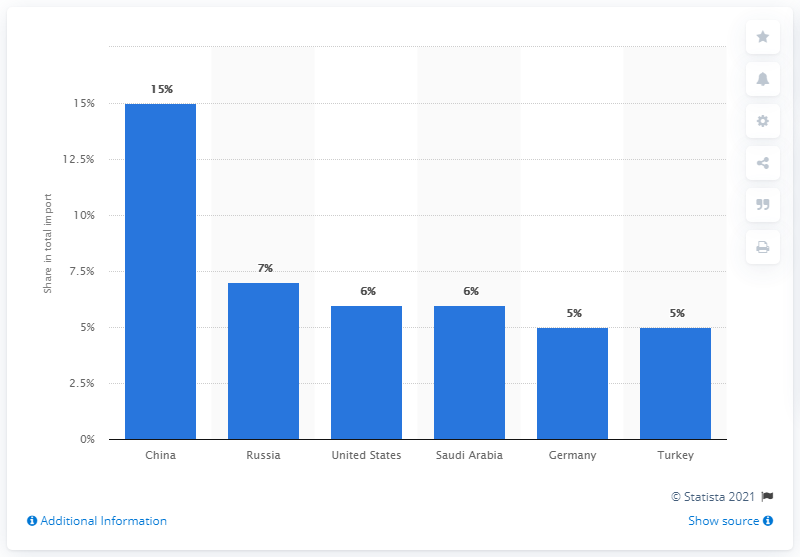List a handful of essential elements in this visual. In 2019, Egypt's most important import partner was China. 